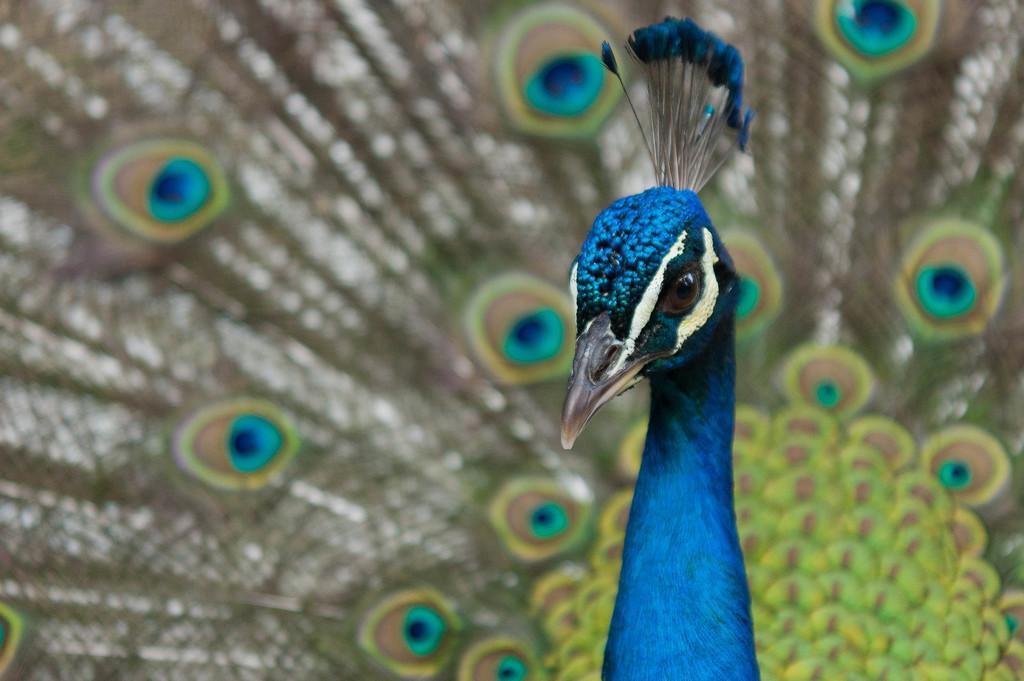Could you give a brief overview of what you see in this image? In this image I can see a peacock. 